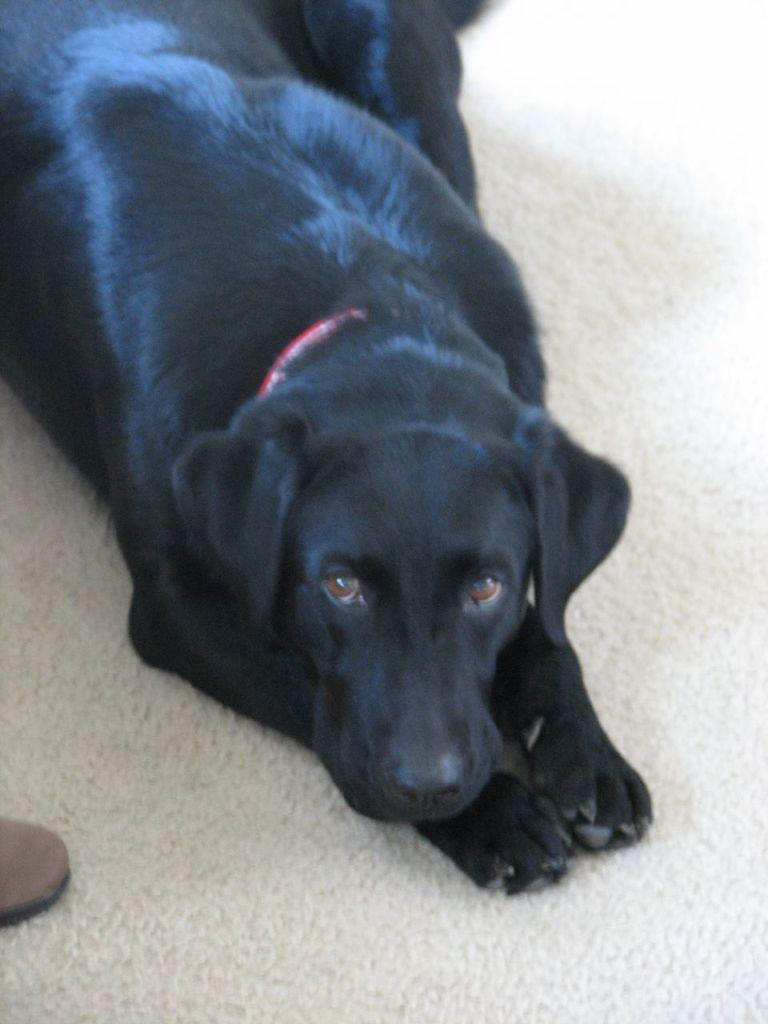What type of animal is present in the image? There is a dog in the image. What is the dog doing in the image? The dog is lying on the floor. How many horses are participating in the show in the image? There are no horses or shows present in the image; it features a dog lying on the floor. 